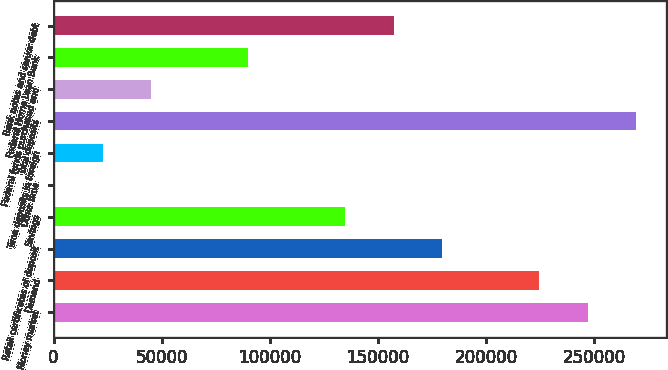Convert chart. <chart><loc_0><loc_0><loc_500><loc_500><bar_chart><fcel>Money market<fcel>Demand<fcel>Retail certificates of deposit<fcel>Savings<fcel>Other time<fcel>Time deposits in foreign<fcel>Total deposits<fcel>Federal funds purchased and<fcel>Federal Home Loan Bank<fcel>Bank notes and senior debt<nl><fcel>247104<fcel>224670<fcel>179801<fcel>134933<fcel>327<fcel>22761.3<fcel>269539<fcel>45195.6<fcel>90064.2<fcel>157367<nl></chart> 